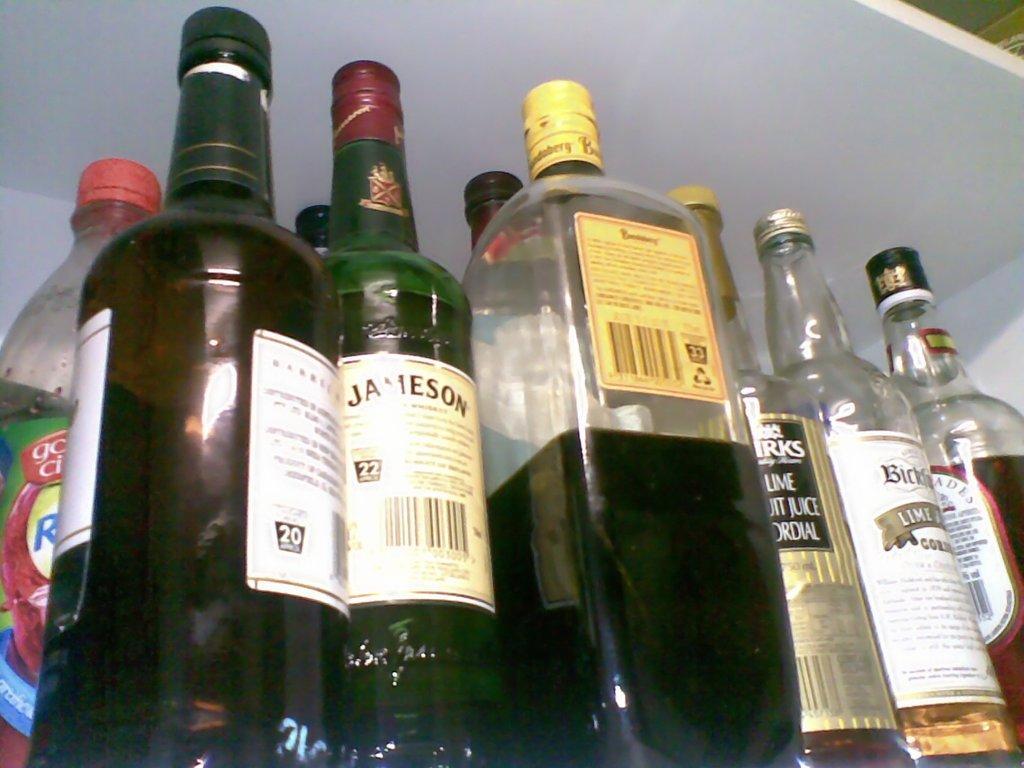How would you summarize this image in a sentence or two? Here we can see a group of wine bottles, and label on it. 